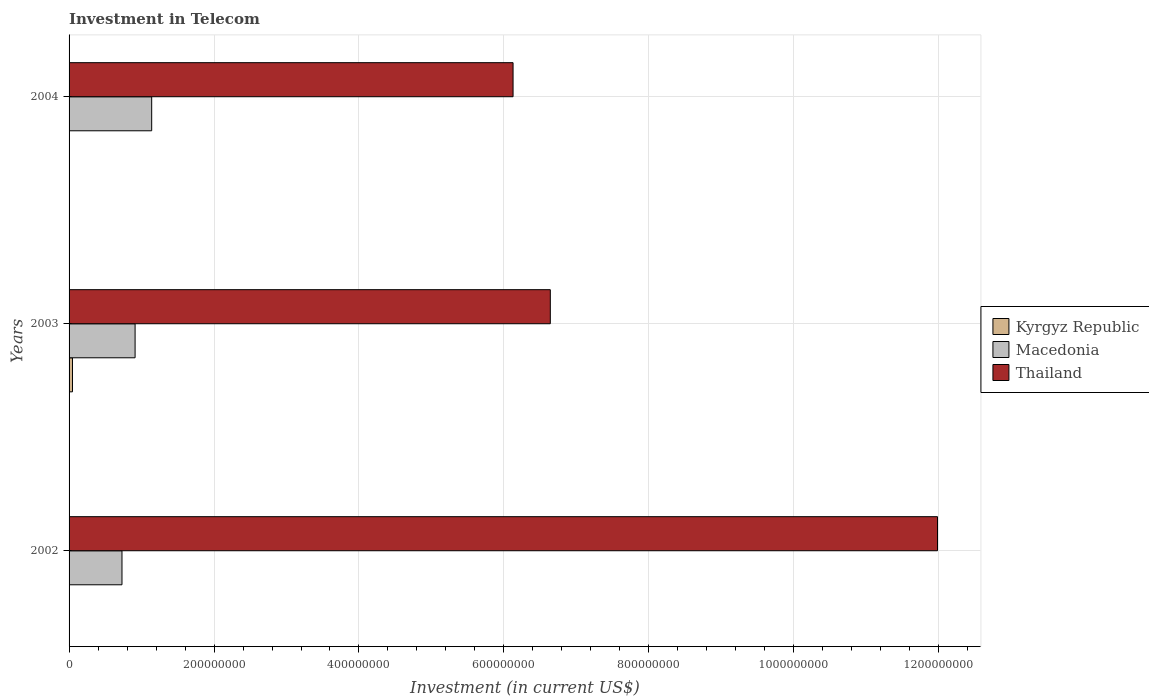Are the number of bars on each tick of the Y-axis equal?
Ensure brevity in your answer.  Yes. How many bars are there on the 3rd tick from the bottom?
Ensure brevity in your answer.  3. Across all years, what is the maximum amount invested in telecom in Thailand?
Ensure brevity in your answer.  1.20e+09. Across all years, what is the minimum amount invested in telecom in Kyrgyz Republic?
Offer a very short reply. 6.00e+05. In which year was the amount invested in telecom in Thailand maximum?
Keep it short and to the point. 2002. What is the total amount invested in telecom in Thailand in the graph?
Offer a terse response. 2.47e+09. What is the difference between the amount invested in telecom in Macedonia in 2002 and that in 2003?
Keep it short and to the point. -1.81e+07. What is the difference between the amount invested in telecom in Macedonia in 2004 and the amount invested in telecom in Kyrgyz Republic in 2002?
Offer a very short reply. 1.13e+08. What is the average amount invested in telecom in Macedonia per year?
Provide a succinct answer. 9.27e+07. In the year 2004, what is the difference between the amount invested in telecom in Macedonia and amount invested in telecom in Thailand?
Provide a short and direct response. -4.99e+08. In how many years, is the amount invested in telecom in Macedonia greater than 1000000000 US$?
Your response must be concise. 0. Is the amount invested in telecom in Kyrgyz Republic in 2002 less than that in 2003?
Ensure brevity in your answer.  Yes. Is the difference between the amount invested in telecom in Macedonia in 2002 and 2003 greater than the difference between the amount invested in telecom in Thailand in 2002 and 2003?
Provide a short and direct response. No. What is the difference between the highest and the second highest amount invested in telecom in Kyrgyz Republic?
Ensure brevity in your answer.  4.10e+06. What is the difference between the highest and the lowest amount invested in telecom in Kyrgyz Republic?
Keep it short and to the point. 4.10e+06. In how many years, is the amount invested in telecom in Kyrgyz Republic greater than the average amount invested in telecom in Kyrgyz Republic taken over all years?
Your response must be concise. 1. Is the sum of the amount invested in telecom in Kyrgyz Republic in 2002 and 2004 greater than the maximum amount invested in telecom in Thailand across all years?
Provide a short and direct response. No. What does the 3rd bar from the top in 2004 represents?
Give a very brief answer. Kyrgyz Republic. What does the 1st bar from the bottom in 2003 represents?
Keep it short and to the point. Kyrgyz Republic. Are all the bars in the graph horizontal?
Give a very brief answer. Yes. How many years are there in the graph?
Give a very brief answer. 3. What is the difference between two consecutive major ticks on the X-axis?
Make the answer very short. 2.00e+08. Are the values on the major ticks of X-axis written in scientific E-notation?
Your answer should be very brief. No. Where does the legend appear in the graph?
Offer a terse response. Center right. How many legend labels are there?
Provide a short and direct response. 3. How are the legend labels stacked?
Offer a very short reply. Vertical. What is the title of the graph?
Provide a short and direct response. Investment in Telecom. Does "Morocco" appear as one of the legend labels in the graph?
Give a very brief answer. No. What is the label or title of the X-axis?
Your answer should be compact. Investment (in current US$). What is the Investment (in current US$) of Macedonia in 2002?
Your response must be concise. 7.30e+07. What is the Investment (in current US$) in Thailand in 2002?
Offer a very short reply. 1.20e+09. What is the Investment (in current US$) of Kyrgyz Republic in 2003?
Your response must be concise. 4.70e+06. What is the Investment (in current US$) in Macedonia in 2003?
Your answer should be compact. 9.11e+07. What is the Investment (in current US$) in Thailand in 2003?
Provide a succinct answer. 6.64e+08. What is the Investment (in current US$) in Kyrgyz Republic in 2004?
Provide a short and direct response. 6.00e+05. What is the Investment (in current US$) of Macedonia in 2004?
Your answer should be very brief. 1.14e+08. What is the Investment (in current US$) of Thailand in 2004?
Offer a very short reply. 6.13e+08. Across all years, what is the maximum Investment (in current US$) of Kyrgyz Republic?
Your answer should be compact. 4.70e+06. Across all years, what is the maximum Investment (in current US$) of Macedonia?
Your answer should be very brief. 1.14e+08. Across all years, what is the maximum Investment (in current US$) of Thailand?
Your response must be concise. 1.20e+09. Across all years, what is the minimum Investment (in current US$) in Kyrgyz Republic?
Offer a very short reply. 6.00e+05. Across all years, what is the minimum Investment (in current US$) in Macedonia?
Offer a very short reply. 7.30e+07. Across all years, what is the minimum Investment (in current US$) of Thailand?
Your answer should be very brief. 6.13e+08. What is the total Investment (in current US$) in Kyrgyz Republic in the graph?
Give a very brief answer. 5.90e+06. What is the total Investment (in current US$) of Macedonia in the graph?
Ensure brevity in your answer.  2.78e+08. What is the total Investment (in current US$) of Thailand in the graph?
Make the answer very short. 2.47e+09. What is the difference between the Investment (in current US$) in Kyrgyz Republic in 2002 and that in 2003?
Make the answer very short. -4.10e+06. What is the difference between the Investment (in current US$) in Macedonia in 2002 and that in 2003?
Offer a terse response. -1.81e+07. What is the difference between the Investment (in current US$) of Thailand in 2002 and that in 2003?
Provide a short and direct response. 5.34e+08. What is the difference between the Investment (in current US$) in Kyrgyz Republic in 2002 and that in 2004?
Provide a succinct answer. 0. What is the difference between the Investment (in current US$) in Macedonia in 2002 and that in 2004?
Offer a very short reply. -4.10e+07. What is the difference between the Investment (in current US$) in Thailand in 2002 and that in 2004?
Your answer should be very brief. 5.86e+08. What is the difference between the Investment (in current US$) of Kyrgyz Republic in 2003 and that in 2004?
Offer a very short reply. 4.10e+06. What is the difference between the Investment (in current US$) in Macedonia in 2003 and that in 2004?
Ensure brevity in your answer.  -2.29e+07. What is the difference between the Investment (in current US$) of Thailand in 2003 and that in 2004?
Provide a short and direct response. 5.14e+07. What is the difference between the Investment (in current US$) of Kyrgyz Republic in 2002 and the Investment (in current US$) of Macedonia in 2003?
Provide a short and direct response. -9.05e+07. What is the difference between the Investment (in current US$) in Kyrgyz Republic in 2002 and the Investment (in current US$) in Thailand in 2003?
Your response must be concise. -6.63e+08. What is the difference between the Investment (in current US$) of Macedonia in 2002 and the Investment (in current US$) of Thailand in 2003?
Keep it short and to the point. -5.91e+08. What is the difference between the Investment (in current US$) in Kyrgyz Republic in 2002 and the Investment (in current US$) in Macedonia in 2004?
Your response must be concise. -1.13e+08. What is the difference between the Investment (in current US$) of Kyrgyz Republic in 2002 and the Investment (in current US$) of Thailand in 2004?
Provide a succinct answer. -6.12e+08. What is the difference between the Investment (in current US$) of Macedonia in 2002 and the Investment (in current US$) of Thailand in 2004?
Make the answer very short. -5.40e+08. What is the difference between the Investment (in current US$) in Kyrgyz Republic in 2003 and the Investment (in current US$) in Macedonia in 2004?
Your response must be concise. -1.09e+08. What is the difference between the Investment (in current US$) of Kyrgyz Republic in 2003 and the Investment (in current US$) of Thailand in 2004?
Provide a short and direct response. -6.08e+08. What is the difference between the Investment (in current US$) of Macedonia in 2003 and the Investment (in current US$) of Thailand in 2004?
Ensure brevity in your answer.  -5.22e+08. What is the average Investment (in current US$) in Kyrgyz Republic per year?
Offer a terse response. 1.97e+06. What is the average Investment (in current US$) of Macedonia per year?
Make the answer very short. 9.27e+07. What is the average Investment (in current US$) of Thailand per year?
Your answer should be very brief. 8.25e+08. In the year 2002, what is the difference between the Investment (in current US$) of Kyrgyz Republic and Investment (in current US$) of Macedonia?
Offer a terse response. -7.24e+07. In the year 2002, what is the difference between the Investment (in current US$) of Kyrgyz Republic and Investment (in current US$) of Thailand?
Give a very brief answer. -1.20e+09. In the year 2002, what is the difference between the Investment (in current US$) in Macedonia and Investment (in current US$) in Thailand?
Offer a terse response. -1.13e+09. In the year 2003, what is the difference between the Investment (in current US$) in Kyrgyz Republic and Investment (in current US$) in Macedonia?
Ensure brevity in your answer.  -8.64e+07. In the year 2003, what is the difference between the Investment (in current US$) in Kyrgyz Republic and Investment (in current US$) in Thailand?
Keep it short and to the point. -6.59e+08. In the year 2003, what is the difference between the Investment (in current US$) of Macedonia and Investment (in current US$) of Thailand?
Offer a very short reply. -5.73e+08. In the year 2004, what is the difference between the Investment (in current US$) of Kyrgyz Republic and Investment (in current US$) of Macedonia?
Offer a very short reply. -1.13e+08. In the year 2004, what is the difference between the Investment (in current US$) in Kyrgyz Republic and Investment (in current US$) in Thailand?
Provide a succinct answer. -6.12e+08. In the year 2004, what is the difference between the Investment (in current US$) of Macedonia and Investment (in current US$) of Thailand?
Provide a succinct answer. -4.99e+08. What is the ratio of the Investment (in current US$) in Kyrgyz Republic in 2002 to that in 2003?
Ensure brevity in your answer.  0.13. What is the ratio of the Investment (in current US$) in Macedonia in 2002 to that in 2003?
Your answer should be very brief. 0.8. What is the ratio of the Investment (in current US$) in Thailand in 2002 to that in 2003?
Give a very brief answer. 1.8. What is the ratio of the Investment (in current US$) of Kyrgyz Republic in 2002 to that in 2004?
Your answer should be very brief. 1. What is the ratio of the Investment (in current US$) of Macedonia in 2002 to that in 2004?
Your answer should be compact. 0.64. What is the ratio of the Investment (in current US$) in Thailand in 2002 to that in 2004?
Ensure brevity in your answer.  1.96. What is the ratio of the Investment (in current US$) in Kyrgyz Republic in 2003 to that in 2004?
Offer a very short reply. 7.83. What is the ratio of the Investment (in current US$) in Macedonia in 2003 to that in 2004?
Your answer should be very brief. 0.8. What is the ratio of the Investment (in current US$) in Thailand in 2003 to that in 2004?
Give a very brief answer. 1.08. What is the difference between the highest and the second highest Investment (in current US$) in Kyrgyz Republic?
Give a very brief answer. 4.10e+06. What is the difference between the highest and the second highest Investment (in current US$) of Macedonia?
Your answer should be compact. 2.29e+07. What is the difference between the highest and the second highest Investment (in current US$) in Thailand?
Keep it short and to the point. 5.34e+08. What is the difference between the highest and the lowest Investment (in current US$) in Kyrgyz Republic?
Offer a very short reply. 4.10e+06. What is the difference between the highest and the lowest Investment (in current US$) of Macedonia?
Offer a terse response. 4.10e+07. What is the difference between the highest and the lowest Investment (in current US$) of Thailand?
Offer a very short reply. 5.86e+08. 